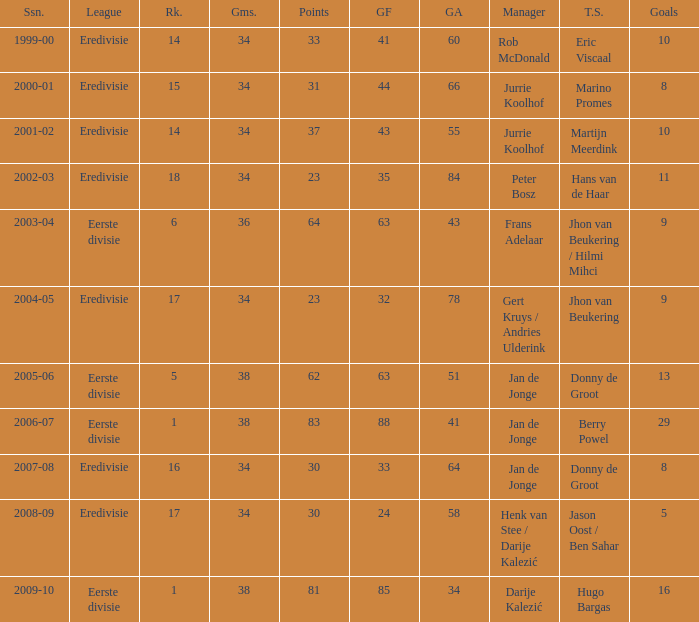Who is the manager whose rank is 16? Jan de Jonge. 